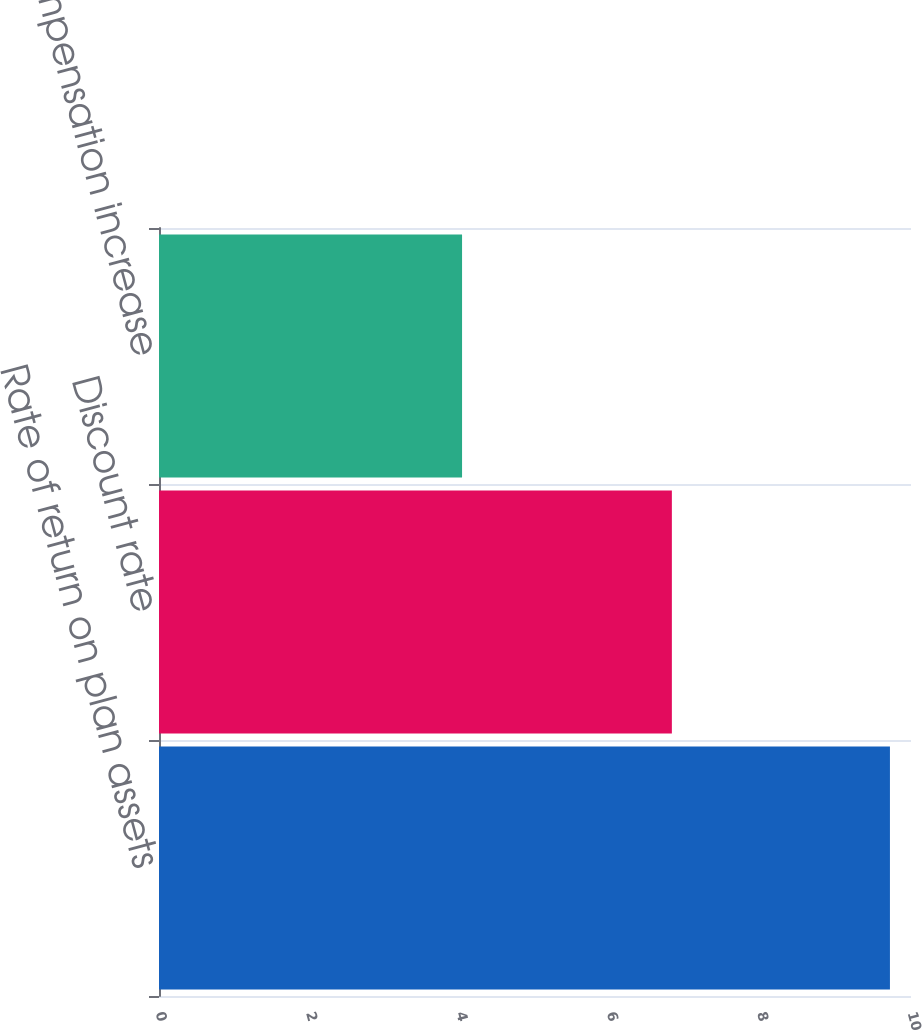Convert chart. <chart><loc_0><loc_0><loc_500><loc_500><bar_chart><fcel>Rate of return on plan assets<fcel>Discount rate<fcel>Rate of compensation increase<nl><fcel>9.72<fcel>6.82<fcel>4.03<nl></chart> 